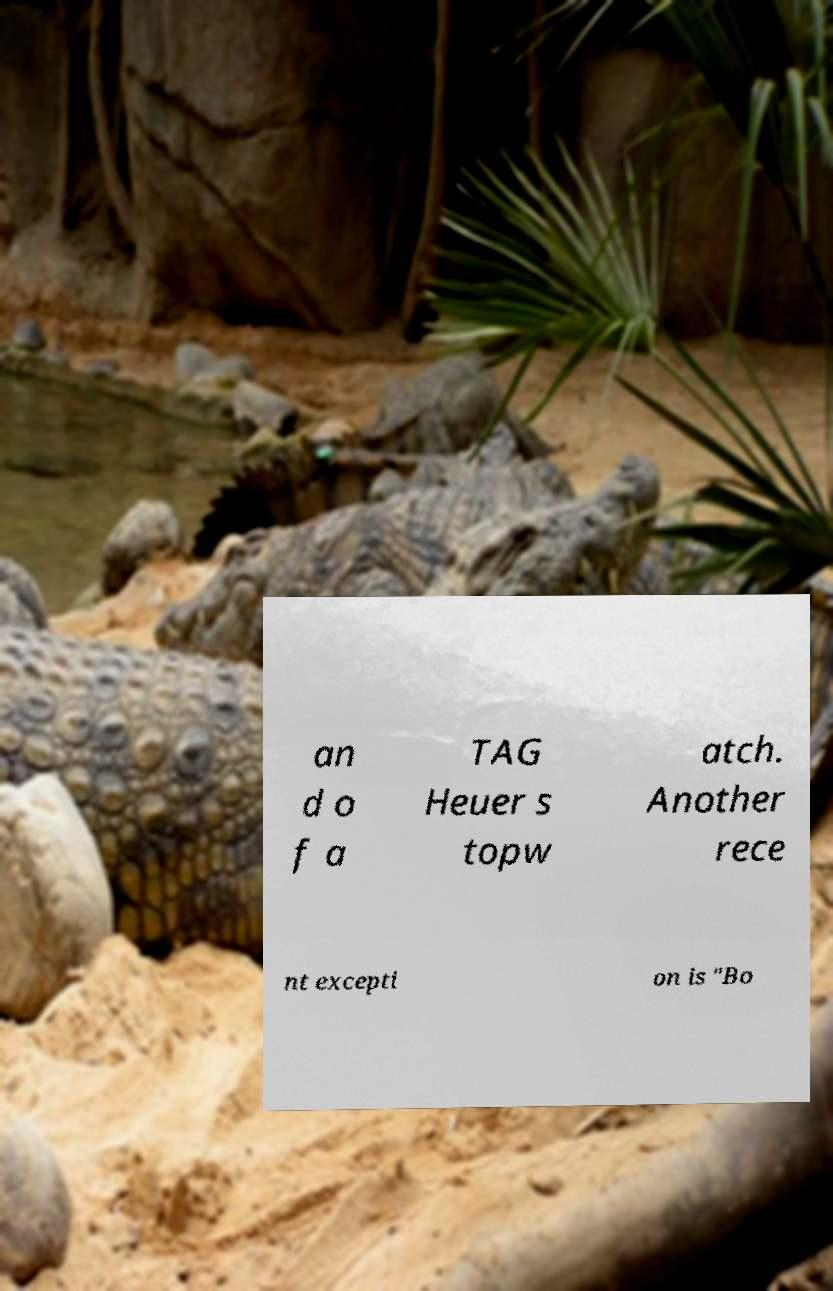Can you read and provide the text displayed in the image?This photo seems to have some interesting text. Can you extract and type it out for me? an d o f a TAG Heuer s topw atch. Another rece nt excepti on is "Bo 